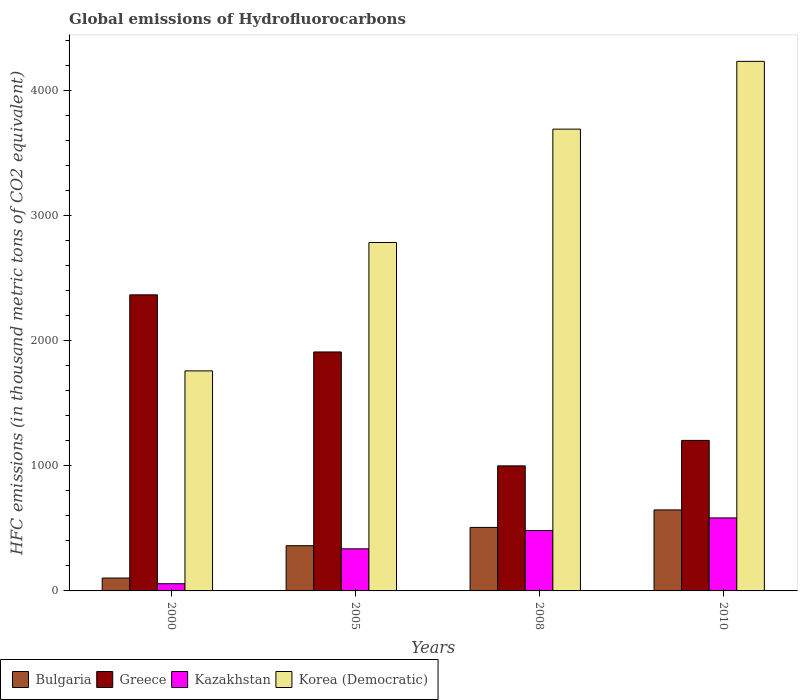How many different coloured bars are there?
Keep it short and to the point. 4. How many groups of bars are there?
Give a very brief answer. 4. Are the number of bars on each tick of the X-axis equal?
Provide a succinct answer. Yes. What is the label of the 3rd group of bars from the left?
Your response must be concise. 2008. What is the global emissions of Hydrofluorocarbons in Bulgaria in 2000?
Your response must be concise. 103.1. Across all years, what is the maximum global emissions of Hydrofluorocarbons in Bulgaria?
Offer a terse response. 648. Across all years, what is the minimum global emissions of Hydrofluorocarbons in Korea (Democratic)?
Offer a very short reply. 1760.1. What is the total global emissions of Hydrofluorocarbons in Greece in the graph?
Offer a terse response. 6484.1. What is the difference between the global emissions of Hydrofluorocarbons in Korea (Democratic) in 2008 and that in 2010?
Offer a terse response. -542.2. What is the difference between the global emissions of Hydrofluorocarbons in Kazakhstan in 2010 and the global emissions of Hydrofluorocarbons in Greece in 2005?
Provide a short and direct response. -1327.4. What is the average global emissions of Hydrofluorocarbons in Greece per year?
Offer a terse response. 1621.03. In the year 2008, what is the difference between the global emissions of Hydrofluorocarbons in Kazakhstan and global emissions of Hydrofluorocarbons in Bulgaria?
Provide a succinct answer. -25.1. What is the ratio of the global emissions of Hydrofluorocarbons in Korea (Democratic) in 2000 to that in 2005?
Ensure brevity in your answer.  0.63. What is the difference between the highest and the second highest global emissions of Hydrofluorocarbons in Greece?
Provide a succinct answer. 457. What is the difference between the highest and the lowest global emissions of Hydrofluorocarbons in Kazakhstan?
Your answer should be compact. 526.5. In how many years, is the global emissions of Hydrofluorocarbons in Bulgaria greater than the average global emissions of Hydrofluorocarbons in Bulgaria taken over all years?
Your answer should be compact. 2. Is it the case that in every year, the sum of the global emissions of Hydrofluorocarbons in Greece and global emissions of Hydrofluorocarbons in Bulgaria is greater than the sum of global emissions of Hydrofluorocarbons in Kazakhstan and global emissions of Hydrofluorocarbons in Korea (Democratic)?
Your answer should be very brief. Yes. What does the 4th bar from the left in 2005 represents?
Provide a succinct answer. Korea (Democratic). What does the 2nd bar from the right in 2000 represents?
Ensure brevity in your answer.  Kazakhstan. How many years are there in the graph?
Keep it short and to the point. 4. What is the difference between two consecutive major ticks on the Y-axis?
Offer a very short reply. 1000. Does the graph contain any zero values?
Your answer should be compact. No. Does the graph contain grids?
Your answer should be compact. No. Where does the legend appear in the graph?
Your answer should be very brief. Bottom left. How are the legend labels stacked?
Offer a very short reply. Horizontal. What is the title of the graph?
Your answer should be very brief. Global emissions of Hydrofluorocarbons. Does "Cuba" appear as one of the legend labels in the graph?
Make the answer very short. No. What is the label or title of the Y-axis?
Keep it short and to the point. HFC emissions (in thousand metric tons of CO2 equivalent). What is the HFC emissions (in thousand metric tons of CO2 equivalent) of Bulgaria in 2000?
Offer a terse response. 103.1. What is the HFC emissions (in thousand metric tons of CO2 equivalent) of Greece in 2000?
Ensure brevity in your answer.  2368.4. What is the HFC emissions (in thousand metric tons of CO2 equivalent) in Kazakhstan in 2000?
Your answer should be very brief. 57.5. What is the HFC emissions (in thousand metric tons of CO2 equivalent) of Korea (Democratic) in 2000?
Make the answer very short. 1760.1. What is the HFC emissions (in thousand metric tons of CO2 equivalent) in Bulgaria in 2005?
Offer a very short reply. 361.6. What is the HFC emissions (in thousand metric tons of CO2 equivalent) in Greece in 2005?
Your answer should be very brief. 1911.4. What is the HFC emissions (in thousand metric tons of CO2 equivalent) in Kazakhstan in 2005?
Your answer should be very brief. 336.7. What is the HFC emissions (in thousand metric tons of CO2 equivalent) in Korea (Democratic) in 2005?
Give a very brief answer. 2787.1. What is the HFC emissions (in thousand metric tons of CO2 equivalent) in Bulgaria in 2008?
Offer a terse response. 508. What is the HFC emissions (in thousand metric tons of CO2 equivalent) in Greece in 2008?
Ensure brevity in your answer.  1000.3. What is the HFC emissions (in thousand metric tons of CO2 equivalent) of Kazakhstan in 2008?
Your answer should be very brief. 482.9. What is the HFC emissions (in thousand metric tons of CO2 equivalent) of Korea (Democratic) in 2008?
Give a very brief answer. 3693.8. What is the HFC emissions (in thousand metric tons of CO2 equivalent) in Bulgaria in 2010?
Ensure brevity in your answer.  648. What is the HFC emissions (in thousand metric tons of CO2 equivalent) of Greece in 2010?
Provide a succinct answer. 1204. What is the HFC emissions (in thousand metric tons of CO2 equivalent) in Kazakhstan in 2010?
Offer a very short reply. 584. What is the HFC emissions (in thousand metric tons of CO2 equivalent) in Korea (Democratic) in 2010?
Your answer should be compact. 4236. Across all years, what is the maximum HFC emissions (in thousand metric tons of CO2 equivalent) in Bulgaria?
Give a very brief answer. 648. Across all years, what is the maximum HFC emissions (in thousand metric tons of CO2 equivalent) of Greece?
Your response must be concise. 2368.4. Across all years, what is the maximum HFC emissions (in thousand metric tons of CO2 equivalent) in Kazakhstan?
Ensure brevity in your answer.  584. Across all years, what is the maximum HFC emissions (in thousand metric tons of CO2 equivalent) of Korea (Democratic)?
Give a very brief answer. 4236. Across all years, what is the minimum HFC emissions (in thousand metric tons of CO2 equivalent) of Bulgaria?
Ensure brevity in your answer.  103.1. Across all years, what is the minimum HFC emissions (in thousand metric tons of CO2 equivalent) of Greece?
Your response must be concise. 1000.3. Across all years, what is the minimum HFC emissions (in thousand metric tons of CO2 equivalent) of Kazakhstan?
Offer a very short reply. 57.5. Across all years, what is the minimum HFC emissions (in thousand metric tons of CO2 equivalent) of Korea (Democratic)?
Offer a terse response. 1760.1. What is the total HFC emissions (in thousand metric tons of CO2 equivalent) of Bulgaria in the graph?
Ensure brevity in your answer.  1620.7. What is the total HFC emissions (in thousand metric tons of CO2 equivalent) in Greece in the graph?
Offer a very short reply. 6484.1. What is the total HFC emissions (in thousand metric tons of CO2 equivalent) of Kazakhstan in the graph?
Ensure brevity in your answer.  1461.1. What is the total HFC emissions (in thousand metric tons of CO2 equivalent) in Korea (Democratic) in the graph?
Provide a succinct answer. 1.25e+04. What is the difference between the HFC emissions (in thousand metric tons of CO2 equivalent) in Bulgaria in 2000 and that in 2005?
Keep it short and to the point. -258.5. What is the difference between the HFC emissions (in thousand metric tons of CO2 equivalent) in Greece in 2000 and that in 2005?
Provide a succinct answer. 457. What is the difference between the HFC emissions (in thousand metric tons of CO2 equivalent) in Kazakhstan in 2000 and that in 2005?
Give a very brief answer. -279.2. What is the difference between the HFC emissions (in thousand metric tons of CO2 equivalent) in Korea (Democratic) in 2000 and that in 2005?
Offer a very short reply. -1027. What is the difference between the HFC emissions (in thousand metric tons of CO2 equivalent) of Bulgaria in 2000 and that in 2008?
Keep it short and to the point. -404.9. What is the difference between the HFC emissions (in thousand metric tons of CO2 equivalent) in Greece in 2000 and that in 2008?
Offer a very short reply. 1368.1. What is the difference between the HFC emissions (in thousand metric tons of CO2 equivalent) of Kazakhstan in 2000 and that in 2008?
Your answer should be compact. -425.4. What is the difference between the HFC emissions (in thousand metric tons of CO2 equivalent) of Korea (Democratic) in 2000 and that in 2008?
Give a very brief answer. -1933.7. What is the difference between the HFC emissions (in thousand metric tons of CO2 equivalent) in Bulgaria in 2000 and that in 2010?
Your response must be concise. -544.9. What is the difference between the HFC emissions (in thousand metric tons of CO2 equivalent) in Greece in 2000 and that in 2010?
Offer a very short reply. 1164.4. What is the difference between the HFC emissions (in thousand metric tons of CO2 equivalent) of Kazakhstan in 2000 and that in 2010?
Keep it short and to the point. -526.5. What is the difference between the HFC emissions (in thousand metric tons of CO2 equivalent) in Korea (Democratic) in 2000 and that in 2010?
Provide a short and direct response. -2475.9. What is the difference between the HFC emissions (in thousand metric tons of CO2 equivalent) of Bulgaria in 2005 and that in 2008?
Make the answer very short. -146.4. What is the difference between the HFC emissions (in thousand metric tons of CO2 equivalent) in Greece in 2005 and that in 2008?
Provide a short and direct response. 911.1. What is the difference between the HFC emissions (in thousand metric tons of CO2 equivalent) of Kazakhstan in 2005 and that in 2008?
Give a very brief answer. -146.2. What is the difference between the HFC emissions (in thousand metric tons of CO2 equivalent) of Korea (Democratic) in 2005 and that in 2008?
Your answer should be compact. -906.7. What is the difference between the HFC emissions (in thousand metric tons of CO2 equivalent) in Bulgaria in 2005 and that in 2010?
Ensure brevity in your answer.  -286.4. What is the difference between the HFC emissions (in thousand metric tons of CO2 equivalent) in Greece in 2005 and that in 2010?
Keep it short and to the point. 707.4. What is the difference between the HFC emissions (in thousand metric tons of CO2 equivalent) of Kazakhstan in 2005 and that in 2010?
Keep it short and to the point. -247.3. What is the difference between the HFC emissions (in thousand metric tons of CO2 equivalent) of Korea (Democratic) in 2005 and that in 2010?
Give a very brief answer. -1448.9. What is the difference between the HFC emissions (in thousand metric tons of CO2 equivalent) in Bulgaria in 2008 and that in 2010?
Your answer should be very brief. -140. What is the difference between the HFC emissions (in thousand metric tons of CO2 equivalent) of Greece in 2008 and that in 2010?
Provide a short and direct response. -203.7. What is the difference between the HFC emissions (in thousand metric tons of CO2 equivalent) of Kazakhstan in 2008 and that in 2010?
Your answer should be very brief. -101.1. What is the difference between the HFC emissions (in thousand metric tons of CO2 equivalent) in Korea (Democratic) in 2008 and that in 2010?
Give a very brief answer. -542.2. What is the difference between the HFC emissions (in thousand metric tons of CO2 equivalent) in Bulgaria in 2000 and the HFC emissions (in thousand metric tons of CO2 equivalent) in Greece in 2005?
Offer a terse response. -1808.3. What is the difference between the HFC emissions (in thousand metric tons of CO2 equivalent) of Bulgaria in 2000 and the HFC emissions (in thousand metric tons of CO2 equivalent) of Kazakhstan in 2005?
Ensure brevity in your answer.  -233.6. What is the difference between the HFC emissions (in thousand metric tons of CO2 equivalent) of Bulgaria in 2000 and the HFC emissions (in thousand metric tons of CO2 equivalent) of Korea (Democratic) in 2005?
Provide a short and direct response. -2684. What is the difference between the HFC emissions (in thousand metric tons of CO2 equivalent) of Greece in 2000 and the HFC emissions (in thousand metric tons of CO2 equivalent) of Kazakhstan in 2005?
Offer a terse response. 2031.7. What is the difference between the HFC emissions (in thousand metric tons of CO2 equivalent) in Greece in 2000 and the HFC emissions (in thousand metric tons of CO2 equivalent) in Korea (Democratic) in 2005?
Your response must be concise. -418.7. What is the difference between the HFC emissions (in thousand metric tons of CO2 equivalent) in Kazakhstan in 2000 and the HFC emissions (in thousand metric tons of CO2 equivalent) in Korea (Democratic) in 2005?
Your answer should be very brief. -2729.6. What is the difference between the HFC emissions (in thousand metric tons of CO2 equivalent) in Bulgaria in 2000 and the HFC emissions (in thousand metric tons of CO2 equivalent) in Greece in 2008?
Provide a short and direct response. -897.2. What is the difference between the HFC emissions (in thousand metric tons of CO2 equivalent) in Bulgaria in 2000 and the HFC emissions (in thousand metric tons of CO2 equivalent) in Kazakhstan in 2008?
Offer a very short reply. -379.8. What is the difference between the HFC emissions (in thousand metric tons of CO2 equivalent) in Bulgaria in 2000 and the HFC emissions (in thousand metric tons of CO2 equivalent) in Korea (Democratic) in 2008?
Offer a terse response. -3590.7. What is the difference between the HFC emissions (in thousand metric tons of CO2 equivalent) of Greece in 2000 and the HFC emissions (in thousand metric tons of CO2 equivalent) of Kazakhstan in 2008?
Provide a succinct answer. 1885.5. What is the difference between the HFC emissions (in thousand metric tons of CO2 equivalent) of Greece in 2000 and the HFC emissions (in thousand metric tons of CO2 equivalent) of Korea (Democratic) in 2008?
Keep it short and to the point. -1325.4. What is the difference between the HFC emissions (in thousand metric tons of CO2 equivalent) in Kazakhstan in 2000 and the HFC emissions (in thousand metric tons of CO2 equivalent) in Korea (Democratic) in 2008?
Give a very brief answer. -3636.3. What is the difference between the HFC emissions (in thousand metric tons of CO2 equivalent) of Bulgaria in 2000 and the HFC emissions (in thousand metric tons of CO2 equivalent) of Greece in 2010?
Your response must be concise. -1100.9. What is the difference between the HFC emissions (in thousand metric tons of CO2 equivalent) in Bulgaria in 2000 and the HFC emissions (in thousand metric tons of CO2 equivalent) in Kazakhstan in 2010?
Give a very brief answer. -480.9. What is the difference between the HFC emissions (in thousand metric tons of CO2 equivalent) of Bulgaria in 2000 and the HFC emissions (in thousand metric tons of CO2 equivalent) of Korea (Democratic) in 2010?
Your answer should be very brief. -4132.9. What is the difference between the HFC emissions (in thousand metric tons of CO2 equivalent) of Greece in 2000 and the HFC emissions (in thousand metric tons of CO2 equivalent) of Kazakhstan in 2010?
Your response must be concise. 1784.4. What is the difference between the HFC emissions (in thousand metric tons of CO2 equivalent) of Greece in 2000 and the HFC emissions (in thousand metric tons of CO2 equivalent) of Korea (Democratic) in 2010?
Your answer should be compact. -1867.6. What is the difference between the HFC emissions (in thousand metric tons of CO2 equivalent) of Kazakhstan in 2000 and the HFC emissions (in thousand metric tons of CO2 equivalent) of Korea (Democratic) in 2010?
Ensure brevity in your answer.  -4178.5. What is the difference between the HFC emissions (in thousand metric tons of CO2 equivalent) in Bulgaria in 2005 and the HFC emissions (in thousand metric tons of CO2 equivalent) in Greece in 2008?
Provide a succinct answer. -638.7. What is the difference between the HFC emissions (in thousand metric tons of CO2 equivalent) of Bulgaria in 2005 and the HFC emissions (in thousand metric tons of CO2 equivalent) of Kazakhstan in 2008?
Provide a succinct answer. -121.3. What is the difference between the HFC emissions (in thousand metric tons of CO2 equivalent) of Bulgaria in 2005 and the HFC emissions (in thousand metric tons of CO2 equivalent) of Korea (Democratic) in 2008?
Offer a very short reply. -3332.2. What is the difference between the HFC emissions (in thousand metric tons of CO2 equivalent) in Greece in 2005 and the HFC emissions (in thousand metric tons of CO2 equivalent) in Kazakhstan in 2008?
Keep it short and to the point. 1428.5. What is the difference between the HFC emissions (in thousand metric tons of CO2 equivalent) of Greece in 2005 and the HFC emissions (in thousand metric tons of CO2 equivalent) of Korea (Democratic) in 2008?
Offer a very short reply. -1782.4. What is the difference between the HFC emissions (in thousand metric tons of CO2 equivalent) in Kazakhstan in 2005 and the HFC emissions (in thousand metric tons of CO2 equivalent) in Korea (Democratic) in 2008?
Provide a succinct answer. -3357.1. What is the difference between the HFC emissions (in thousand metric tons of CO2 equivalent) of Bulgaria in 2005 and the HFC emissions (in thousand metric tons of CO2 equivalent) of Greece in 2010?
Give a very brief answer. -842.4. What is the difference between the HFC emissions (in thousand metric tons of CO2 equivalent) in Bulgaria in 2005 and the HFC emissions (in thousand metric tons of CO2 equivalent) in Kazakhstan in 2010?
Ensure brevity in your answer.  -222.4. What is the difference between the HFC emissions (in thousand metric tons of CO2 equivalent) of Bulgaria in 2005 and the HFC emissions (in thousand metric tons of CO2 equivalent) of Korea (Democratic) in 2010?
Make the answer very short. -3874.4. What is the difference between the HFC emissions (in thousand metric tons of CO2 equivalent) of Greece in 2005 and the HFC emissions (in thousand metric tons of CO2 equivalent) of Kazakhstan in 2010?
Your answer should be very brief. 1327.4. What is the difference between the HFC emissions (in thousand metric tons of CO2 equivalent) in Greece in 2005 and the HFC emissions (in thousand metric tons of CO2 equivalent) in Korea (Democratic) in 2010?
Provide a short and direct response. -2324.6. What is the difference between the HFC emissions (in thousand metric tons of CO2 equivalent) in Kazakhstan in 2005 and the HFC emissions (in thousand metric tons of CO2 equivalent) in Korea (Democratic) in 2010?
Provide a short and direct response. -3899.3. What is the difference between the HFC emissions (in thousand metric tons of CO2 equivalent) in Bulgaria in 2008 and the HFC emissions (in thousand metric tons of CO2 equivalent) in Greece in 2010?
Give a very brief answer. -696. What is the difference between the HFC emissions (in thousand metric tons of CO2 equivalent) of Bulgaria in 2008 and the HFC emissions (in thousand metric tons of CO2 equivalent) of Kazakhstan in 2010?
Your answer should be very brief. -76. What is the difference between the HFC emissions (in thousand metric tons of CO2 equivalent) in Bulgaria in 2008 and the HFC emissions (in thousand metric tons of CO2 equivalent) in Korea (Democratic) in 2010?
Keep it short and to the point. -3728. What is the difference between the HFC emissions (in thousand metric tons of CO2 equivalent) in Greece in 2008 and the HFC emissions (in thousand metric tons of CO2 equivalent) in Kazakhstan in 2010?
Make the answer very short. 416.3. What is the difference between the HFC emissions (in thousand metric tons of CO2 equivalent) in Greece in 2008 and the HFC emissions (in thousand metric tons of CO2 equivalent) in Korea (Democratic) in 2010?
Provide a succinct answer. -3235.7. What is the difference between the HFC emissions (in thousand metric tons of CO2 equivalent) in Kazakhstan in 2008 and the HFC emissions (in thousand metric tons of CO2 equivalent) in Korea (Democratic) in 2010?
Ensure brevity in your answer.  -3753.1. What is the average HFC emissions (in thousand metric tons of CO2 equivalent) in Bulgaria per year?
Offer a very short reply. 405.18. What is the average HFC emissions (in thousand metric tons of CO2 equivalent) in Greece per year?
Keep it short and to the point. 1621.03. What is the average HFC emissions (in thousand metric tons of CO2 equivalent) in Kazakhstan per year?
Offer a very short reply. 365.27. What is the average HFC emissions (in thousand metric tons of CO2 equivalent) of Korea (Democratic) per year?
Keep it short and to the point. 3119.25. In the year 2000, what is the difference between the HFC emissions (in thousand metric tons of CO2 equivalent) in Bulgaria and HFC emissions (in thousand metric tons of CO2 equivalent) in Greece?
Offer a very short reply. -2265.3. In the year 2000, what is the difference between the HFC emissions (in thousand metric tons of CO2 equivalent) in Bulgaria and HFC emissions (in thousand metric tons of CO2 equivalent) in Kazakhstan?
Provide a short and direct response. 45.6. In the year 2000, what is the difference between the HFC emissions (in thousand metric tons of CO2 equivalent) of Bulgaria and HFC emissions (in thousand metric tons of CO2 equivalent) of Korea (Democratic)?
Provide a succinct answer. -1657. In the year 2000, what is the difference between the HFC emissions (in thousand metric tons of CO2 equivalent) of Greece and HFC emissions (in thousand metric tons of CO2 equivalent) of Kazakhstan?
Offer a terse response. 2310.9. In the year 2000, what is the difference between the HFC emissions (in thousand metric tons of CO2 equivalent) in Greece and HFC emissions (in thousand metric tons of CO2 equivalent) in Korea (Democratic)?
Your answer should be very brief. 608.3. In the year 2000, what is the difference between the HFC emissions (in thousand metric tons of CO2 equivalent) of Kazakhstan and HFC emissions (in thousand metric tons of CO2 equivalent) of Korea (Democratic)?
Your answer should be very brief. -1702.6. In the year 2005, what is the difference between the HFC emissions (in thousand metric tons of CO2 equivalent) of Bulgaria and HFC emissions (in thousand metric tons of CO2 equivalent) of Greece?
Ensure brevity in your answer.  -1549.8. In the year 2005, what is the difference between the HFC emissions (in thousand metric tons of CO2 equivalent) in Bulgaria and HFC emissions (in thousand metric tons of CO2 equivalent) in Kazakhstan?
Your answer should be compact. 24.9. In the year 2005, what is the difference between the HFC emissions (in thousand metric tons of CO2 equivalent) in Bulgaria and HFC emissions (in thousand metric tons of CO2 equivalent) in Korea (Democratic)?
Your answer should be very brief. -2425.5. In the year 2005, what is the difference between the HFC emissions (in thousand metric tons of CO2 equivalent) of Greece and HFC emissions (in thousand metric tons of CO2 equivalent) of Kazakhstan?
Offer a very short reply. 1574.7. In the year 2005, what is the difference between the HFC emissions (in thousand metric tons of CO2 equivalent) in Greece and HFC emissions (in thousand metric tons of CO2 equivalent) in Korea (Democratic)?
Your response must be concise. -875.7. In the year 2005, what is the difference between the HFC emissions (in thousand metric tons of CO2 equivalent) of Kazakhstan and HFC emissions (in thousand metric tons of CO2 equivalent) of Korea (Democratic)?
Offer a terse response. -2450.4. In the year 2008, what is the difference between the HFC emissions (in thousand metric tons of CO2 equivalent) in Bulgaria and HFC emissions (in thousand metric tons of CO2 equivalent) in Greece?
Your answer should be very brief. -492.3. In the year 2008, what is the difference between the HFC emissions (in thousand metric tons of CO2 equivalent) in Bulgaria and HFC emissions (in thousand metric tons of CO2 equivalent) in Kazakhstan?
Ensure brevity in your answer.  25.1. In the year 2008, what is the difference between the HFC emissions (in thousand metric tons of CO2 equivalent) in Bulgaria and HFC emissions (in thousand metric tons of CO2 equivalent) in Korea (Democratic)?
Make the answer very short. -3185.8. In the year 2008, what is the difference between the HFC emissions (in thousand metric tons of CO2 equivalent) of Greece and HFC emissions (in thousand metric tons of CO2 equivalent) of Kazakhstan?
Make the answer very short. 517.4. In the year 2008, what is the difference between the HFC emissions (in thousand metric tons of CO2 equivalent) of Greece and HFC emissions (in thousand metric tons of CO2 equivalent) of Korea (Democratic)?
Provide a succinct answer. -2693.5. In the year 2008, what is the difference between the HFC emissions (in thousand metric tons of CO2 equivalent) of Kazakhstan and HFC emissions (in thousand metric tons of CO2 equivalent) of Korea (Democratic)?
Offer a very short reply. -3210.9. In the year 2010, what is the difference between the HFC emissions (in thousand metric tons of CO2 equivalent) of Bulgaria and HFC emissions (in thousand metric tons of CO2 equivalent) of Greece?
Keep it short and to the point. -556. In the year 2010, what is the difference between the HFC emissions (in thousand metric tons of CO2 equivalent) of Bulgaria and HFC emissions (in thousand metric tons of CO2 equivalent) of Kazakhstan?
Offer a terse response. 64. In the year 2010, what is the difference between the HFC emissions (in thousand metric tons of CO2 equivalent) in Bulgaria and HFC emissions (in thousand metric tons of CO2 equivalent) in Korea (Democratic)?
Ensure brevity in your answer.  -3588. In the year 2010, what is the difference between the HFC emissions (in thousand metric tons of CO2 equivalent) in Greece and HFC emissions (in thousand metric tons of CO2 equivalent) in Kazakhstan?
Your answer should be compact. 620. In the year 2010, what is the difference between the HFC emissions (in thousand metric tons of CO2 equivalent) of Greece and HFC emissions (in thousand metric tons of CO2 equivalent) of Korea (Democratic)?
Provide a succinct answer. -3032. In the year 2010, what is the difference between the HFC emissions (in thousand metric tons of CO2 equivalent) in Kazakhstan and HFC emissions (in thousand metric tons of CO2 equivalent) in Korea (Democratic)?
Your answer should be very brief. -3652. What is the ratio of the HFC emissions (in thousand metric tons of CO2 equivalent) of Bulgaria in 2000 to that in 2005?
Keep it short and to the point. 0.29. What is the ratio of the HFC emissions (in thousand metric tons of CO2 equivalent) of Greece in 2000 to that in 2005?
Make the answer very short. 1.24. What is the ratio of the HFC emissions (in thousand metric tons of CO2 equivalent) in Kazakhstan in 2000 to that in 2005?
Your response must be concise. 0.17. What is the ratio of the HFC emissions (in thousand metric tons of CO2 equivalent) of Korea (Democratic) in 2000 to that in 2005?
Provide a short and direct response. 0.63. What is the ratio of the HFC emissions (in thousand metric tons of CO2 equivalent) of Bulgaria in 2000 to that in 2008?
Your response must be concise. 0.2. What is the ratio of the HFC emissions (in thousand metric tons of CO2 equivalent) of Greece in 2000 to that in 2008?
Give a very brief answer. 2.37. What is the ratio of the HFC emissions (in thousand metric tons of CO2 equivalent) in Kazakhstan in 2000 to that in 2008?
Offer a terse response. 0.12. What is the ratio of the HFC emissions (in thousand metric tons of CO2 equivalent) in Korea (Democratic) in 2000 to that in 2008?
Make the answer very short. 0.48. What is the ratio of the HFC emissions (in thousand metric tons of CO2 equivalent) of Bulgaria in 2000 to that in 2010?
Provide a short and direct response. 0.16. What is the ratio of the HFC emissions (in thousand metric tons of CO2 equivalent) in Greece in 2000 to that in 2010?
Your answer should be compact. 1.97. What is the ratio of the HFC emissions (in thousand metric tons of CO2 equivalent) in Kazakhstan in 2000 to that in 2010?
Provide a succinct answer. 0.1. What is the ratio of the HFC emissions (in thousand metric tons of CO2 equivalent) of Korea (Democratic) in 2000 to that in 2010?
Keep it short and to the point. 0.42. What is the ratio of the HFC emissions (in thousand metric tons of CO2 equivalent) in Bulgaria in 2005 to that in 2008?
Make the answer very short. 0.71. What is the ratio of the HFC emissions (in thousand metric tons of CO2 equivalent) in Greece in 2005 to that in 2008?
Keep it short and to the point. 1.91. What is the ratio of the HFC emissions (in thousand metric tons of CO2 equivalent) in Kazakhstan in 2005 to that in 2008?
Keep it short and to the point. 0.7. What is the ratio of the HFC emissions (in thousand metric tons of CO2 equivalent) of Korea (Democratic) in 2005 to that in 2008?
Provide a short and direct response. 0.75. What is the ratio of the HFC emissions (in thousand metric tons of CO2 equivalent) in Bulgaria in 2005 to that in 2010?
Provide a succinct answer. 0.56. What is the ratio of the HFC emissions (in thousand metric tons of CO2 equivalent) of Greece in 2005 to that in 2010?
Your response must be concise. 1.59. What is the ratio of the HFC emissions (in thousand metric tons of CO2 equivalent) in Kazakhstan in 2005 to that in 2010?
Offer a terse response. 0.58. What is the ratio of the HFC emissions (in thousand metric tons of CO2 equivalent) of Korea (Democratic) in 2005 to that in 2010?
Ensure brevity in your answer.  0.66. What is the ratio of the HFC emissions (in thousand metric tons of CO2 equivalent) in Bulgaria in 2008 to that in 2010?
Provide a succinct answer. 0.78. What is the ratio of the HFC emissions (in thousand metric tons of CO2 equivalent) of Greece in 2008 to that in 2010?
Your answer should be very brief. 0.83. What is the ratio of the HFC emissions (in thousand metric tons of CO2 equivalent) of Kazakhstan in 2008 to that in 2010?
Your response must be concise. 0.83. What is the ratio of the HFC emissions (in thousand metric tons of CO2 equivalent) of Korea (Democratic) in 2008 to that in 2010?
Offer a terse response. 0.87. What is the difference between the highest and the second highest HFC emissions (in thousand metric tons of CO2 equivalent) in Bulgaria?
Your answer should be compact. 140. What is the difference between the highest and the second highest HFC emissions (in thousand metric tons of CO2 equivalent) of Greece?
Give a very brief answer. 457. What is the difference between the highest and the second highest HFC emissions (in thousand metric tons of CO2 equivalent) in Kazakhstan?
Make the answer very short. 101.1. What is the difference between the highest and the second highest HFC emissions (in thousand metric tons of CO2 equivalent) of Korea (Democratic)?
Make the answer very short. 542.2. What is the difference between the highest and the lowest HFC emissions (in thousand metric tons of CO2 equivalent) in Bulgaria?
Your response must be concise. 544.9. What is the difference between the highest and the lowest HFC emissions (in thousand metric tons of CO2 equivalent) in Greece?
Give a very brief answer. 1368.1. What is the difference between the highest and the lowest HFC emissions (in thousand metric tons of CO2 equivalent) of Kazakhstan?
Your answer should be very brief. 526.5. What is the difference between the highest and the lowest HFC emissions (in thousand metric tons of CO2 equivalent) in Korea (Democratic)?
Offer a terse response. 2475.9. 